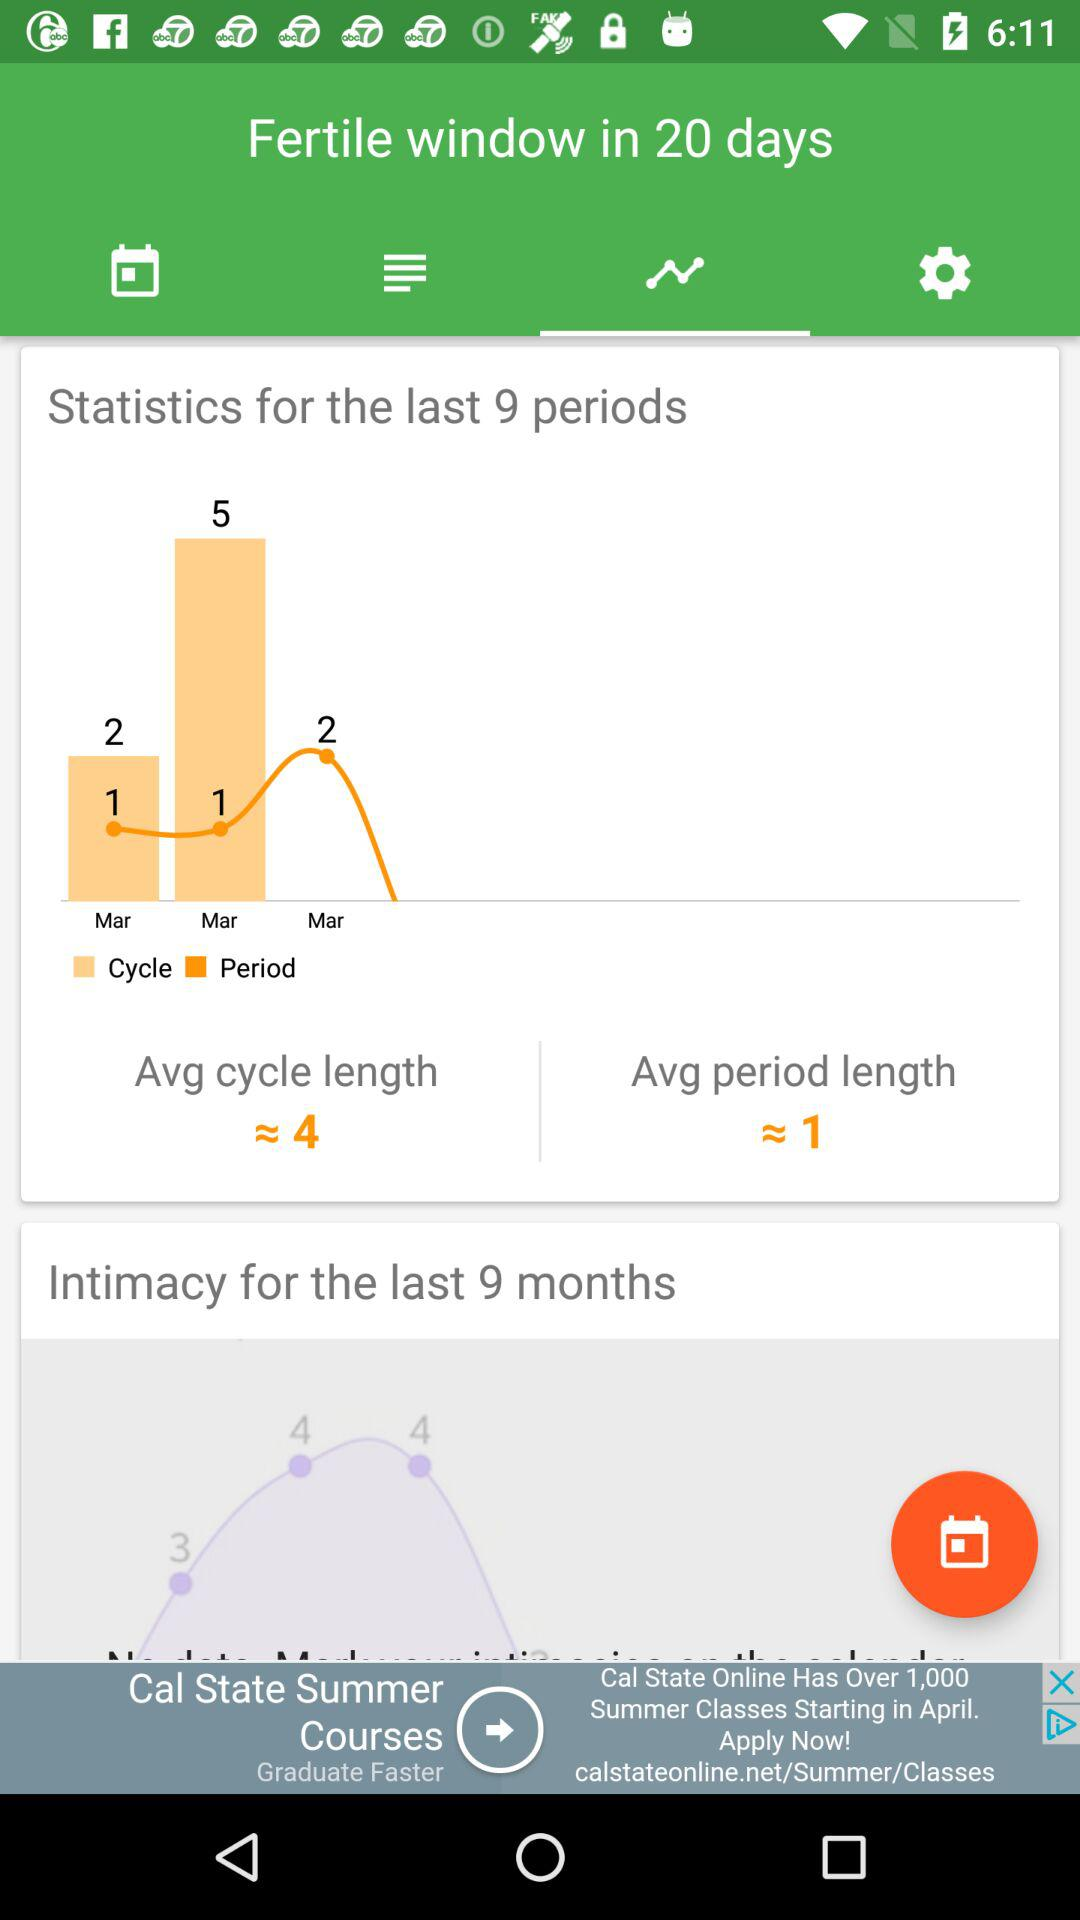How many days is the average cycle length?
Answer the question using a single word or phrase. 4 